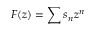<formula> <loc_0><loc_0><loc_500><loc_500>F ( z ) = \sum { s _ { n } z ^ { n } }</formula> 